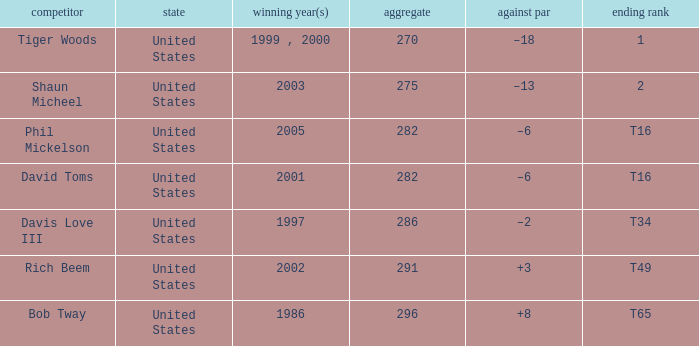What is Davis Love III's total? 286.0. 